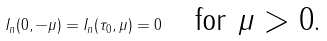Convert formula to latex. <formula><loc_0><loc_0><loc_500><loc_500>I _ { n } ( 0 , - \mu ) = I _ { n } ( \tau _ { 0 } , \mu ) = 0 \quad \text {for $\mu>0$.}</formula> 